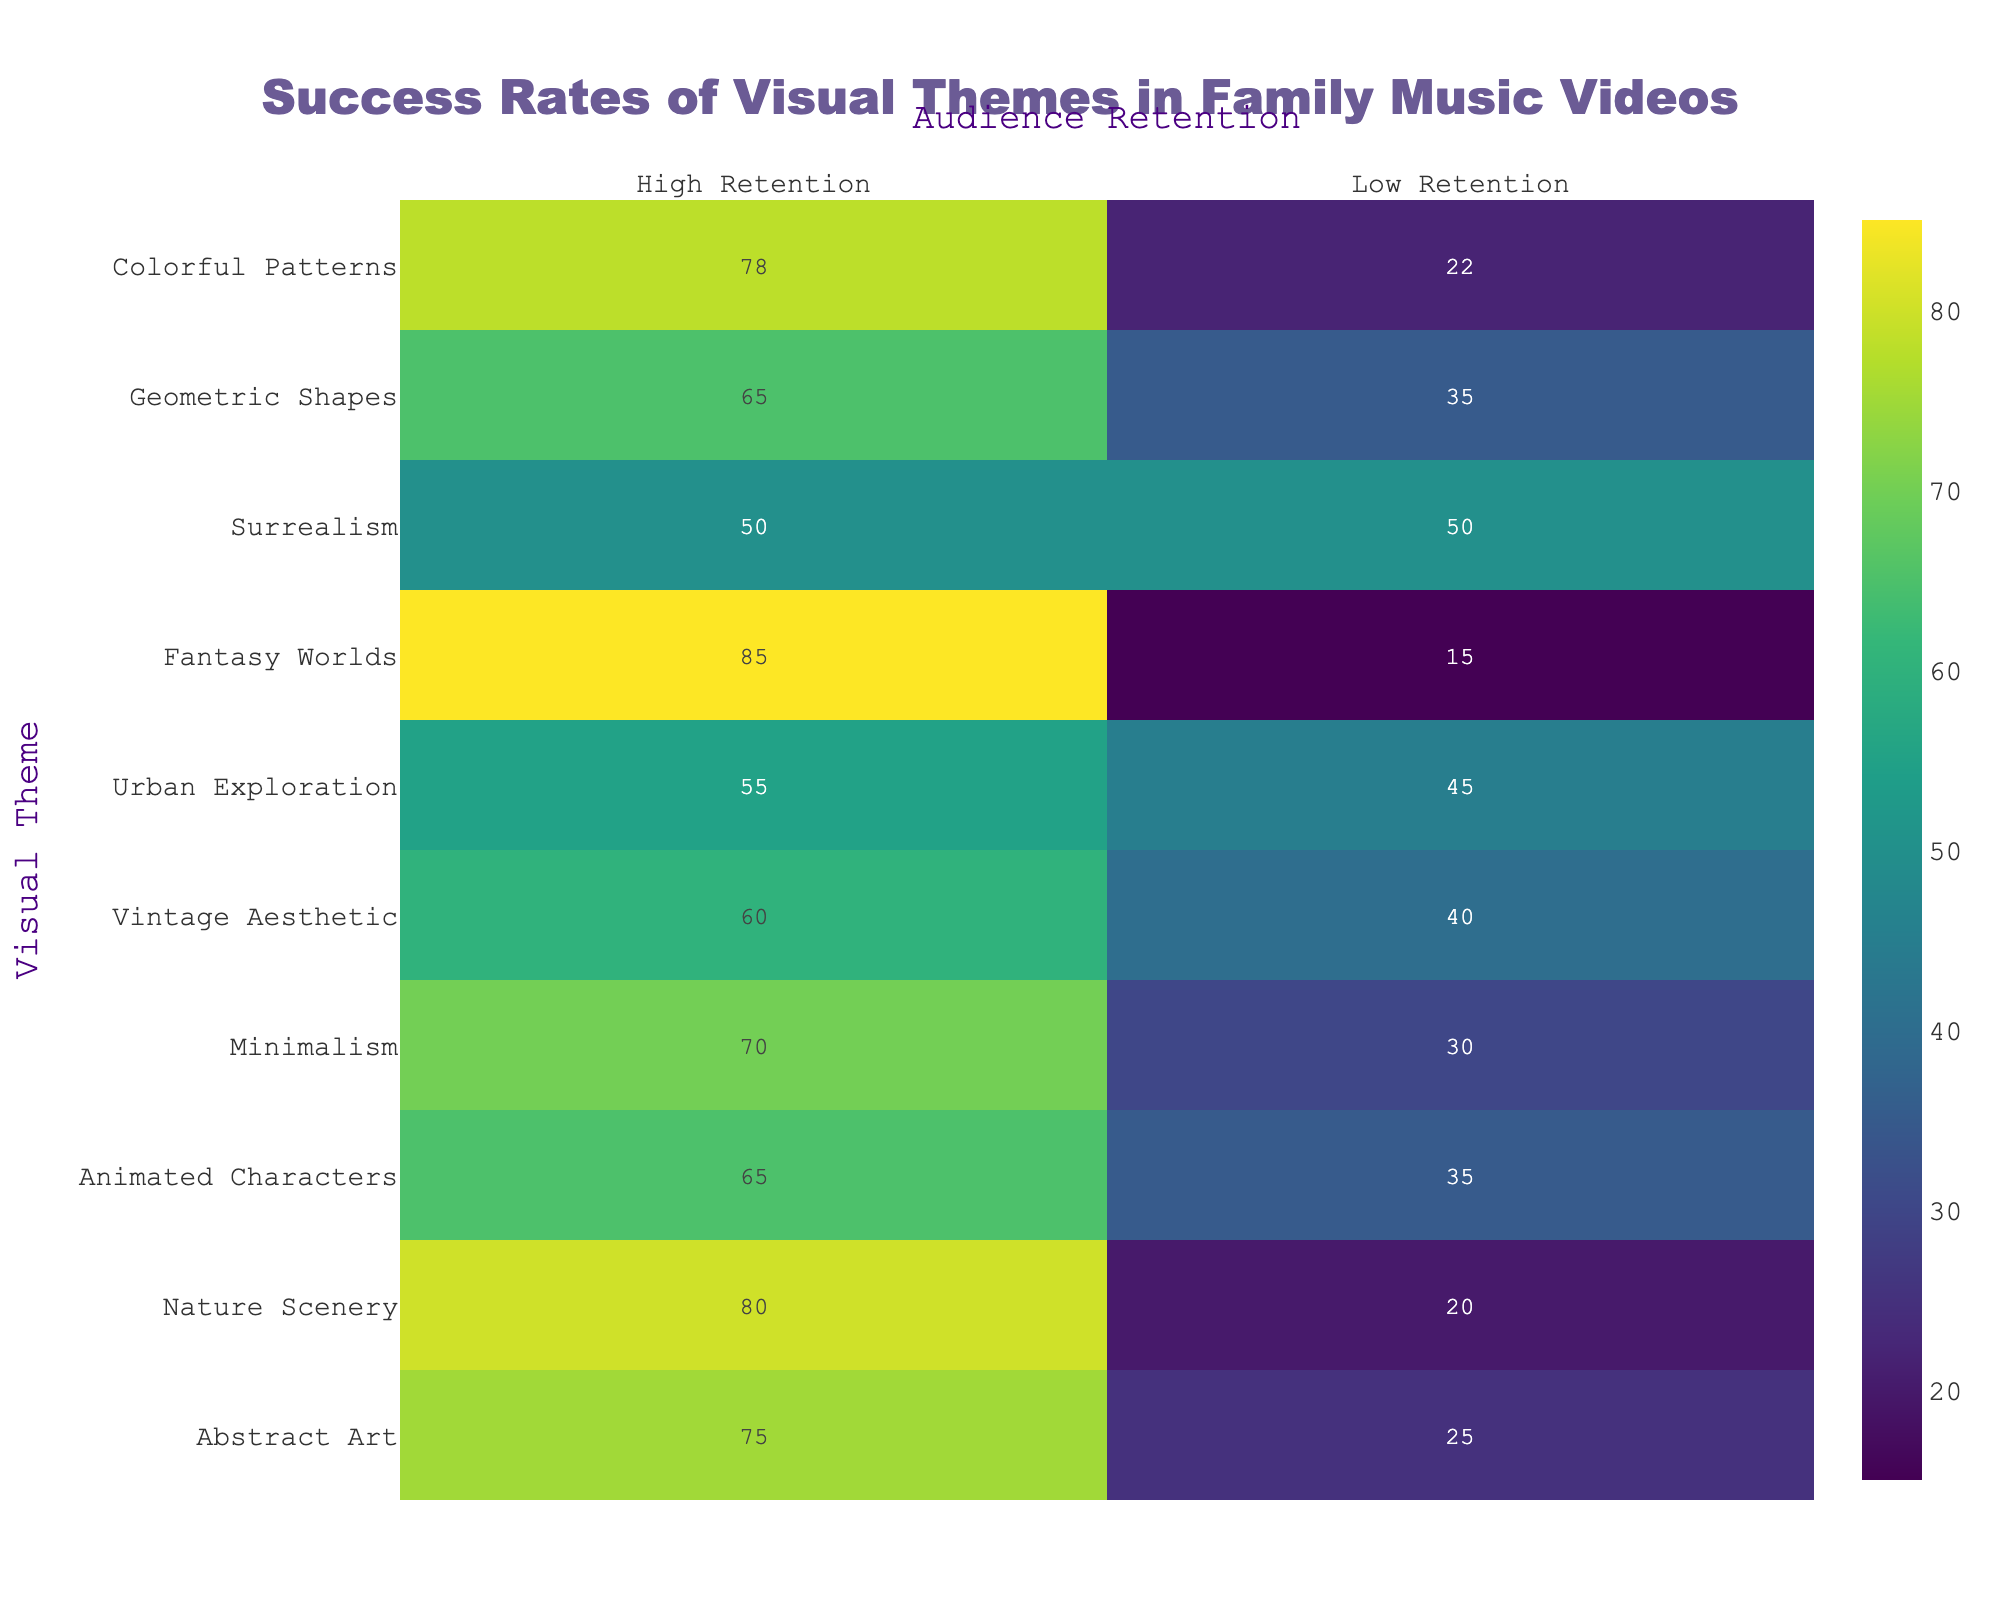What is the high retention rate for Fantasy Worlds? The high retention rate for Fantasy Worlds is given directly in the table under that theme. It states 85 for high retention.
Answer: 85 Which visual theme has the lowest rate of low retention? In the table, we look for the lowest value under the 'Low Retention' column. The lowest value is 15 associated with the theme of Fantasy Worlds.
Answer: Fantasy Worlds What is the average high retention rate of all themes? First, we sum the high retention values: 75 + 80 + 65 + 70 + 60 + 55 + 85 + 50 + 65 + 78 =  765. There are 10 themes, so we divide by 10 to find the average: 765 / 10 = 76.5.
Answer: 76.5 Is the high retention rate for Abstract Art greater than the high retention rate for Urban Exploration? We compare both values: 75 (Abstract Art) and 55 (Urban Exploration). Since 75 is greater than 55, the statement is true.
Answer: Yes Which visual themes have at least 70% high retention? We look through the 'High Retention' column and find the themes with a score of 70 or above: Abstract Art (75), Nature Scenery (80), Minimalism (70), Fantasy Worlds (85), and Colorful Patterns (78).
Answer: Abstract Art, Nature Scenery, Minimalism, Fantasy Worlds, Colorful Patterns What is the difference in high retention rates between Nature Scenery and Vintage Aesthetic? We find the high retention rate for Nature Scenery (80) and Vintage Aesthetic (60). The difference is calculated as 80 - 60 = 20.
Answer: 20 Does Surrealism have a higher low retention rate than Animated Characters? We compare the low retention rates: 50 (Surrealism) and 35 (Animated Characters). Since 50 is greater than 35, the statement is true.
Answer: Yes What is the total number of low retention across all themes? We sum the low retention values: 25 + 20 + 35 + 30 + 40 + 45 + 15 + 50 + 35 + 22 =  312.
Answer: 312 